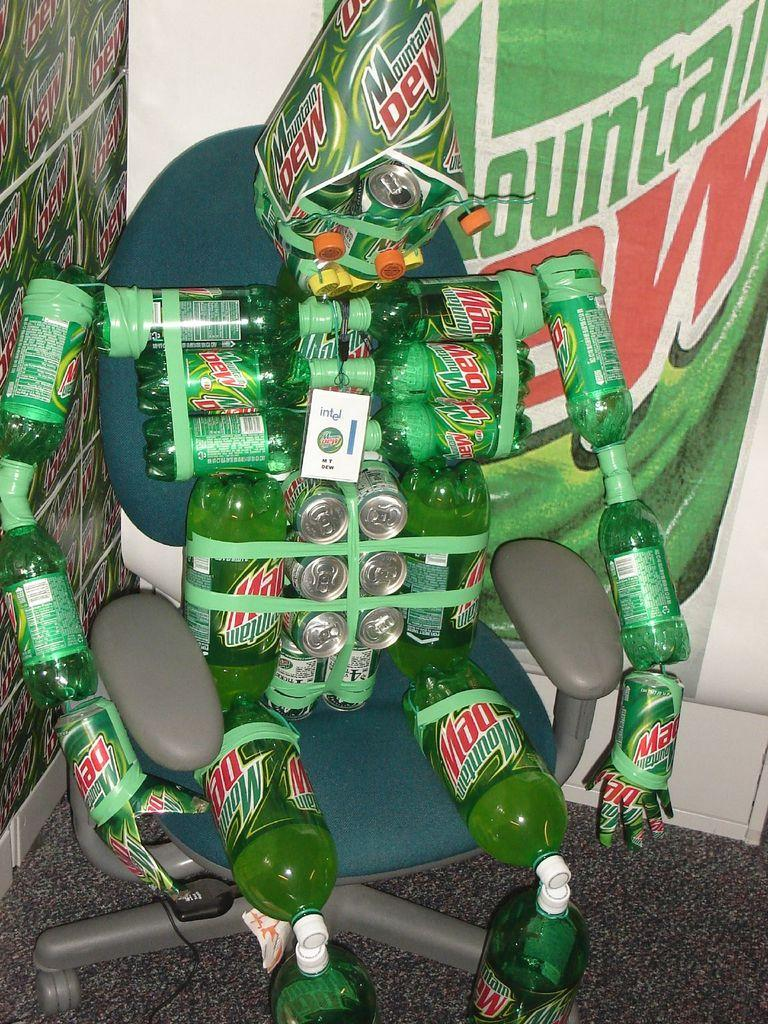<image>
Present a compact description of the photo's key features. Many Mountain Dew products are combined to create a robotic looking figurine. 